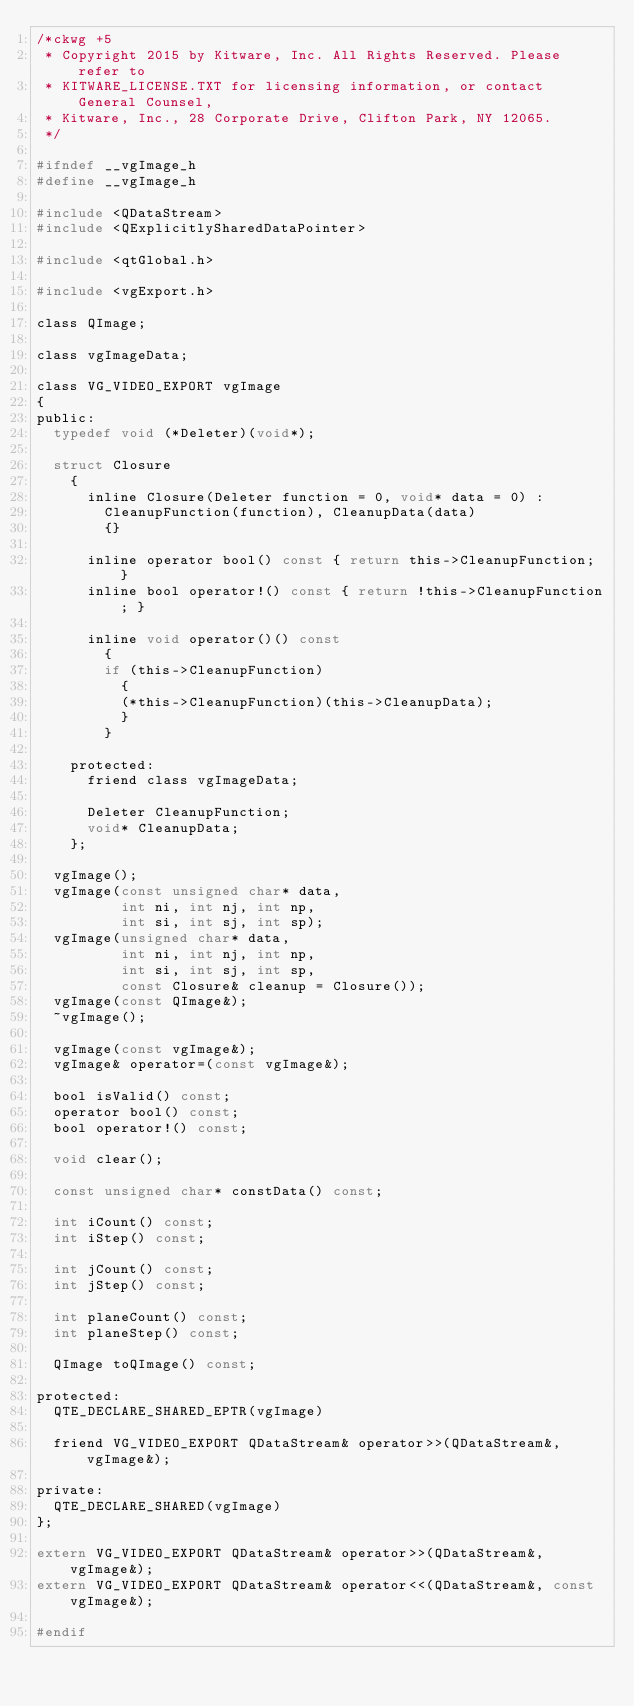<code> <loc_0><loc_0><loc_500><loc_500><_C_>/*ckwg +5
 * Copyright 2015 by Kitware, Inc. All Rights Reserved. Please refer to
 * KITWARE_LICENSE.TXT for licensing information, or contact General Counsel,
 * Kitware, Inc., 28 Corporate Drive, Clifton Park, NY 12065.
 */

#ifndef __vgImage_h
#define __vgImage_h

#include <QDataStream>
#include <QExplicitlySharedDataPointer>

#include <qtGlobal.h>

#include <vgExport.h>

class QImage;

class vgImageData;

class VG_VIDEO_EXPORT vgImage
{
public:
  typedef void (*Deleter)(void*);

  struct Closure
    {
      inline Closure(Deleter function = 0, void* data = 0) :
        CleanupFunction(function), CleanupData(data)
        {}

      inline operator bool() const { return this->CleanupFunction; }
      inline bool operator!() const { return !this->CleanupFunction; }

      inline void operator()() const
        {
        if (this->CleanupFunction)
          {
          (*this->CleanupFunction)(this->CleanupData);
          }
        }

    protected:
      friend class vgImageData;

      Deleter CleanupFunction;
      void* CleanupData;
    };

  vgImage();
  vgImage(const unsigned char* data,
          int ni, int nj, int np,
          int si, int sj, int sp);
  vgImage(unsigned char* data,
          int ni, int nj, int np,
          int si, int sj, int sp,
          const Closure& cleanup = Closure());
  vgImage(const QImage&);
  ~vgImage();

  vgImage(const vgImage&);
  vgImage& operator=(const vgImage&);

  bool isValid() const;
  operator bool() const;
  bool operator!() const;

  void clear();

  const unsigned char* constData() const;

  int iCount() const;
  int iStep() const;

  int jCount() const;
  int jStep() const;

  int planeCount() const;
  int planeStep() const;

  QImage toQImage() const;

protected:
  QTE_DECLARE_SHARED_EPTR(vgImage)

  friend VG_VIDEO_EXPORT QDataStream& operator>>(QDataStream&, vgImage&);

private:
  QTE_DECLARE_SHARED(vgImage)
};

extern VG_VIDEO_EXPORT QDataStream& operator>>(QDataStream&, vgImage&);
extern VG_VIDEO_EXPORT QDataStream& operator<<(QDataStream&, const vgImage&);

#endif
</code> 